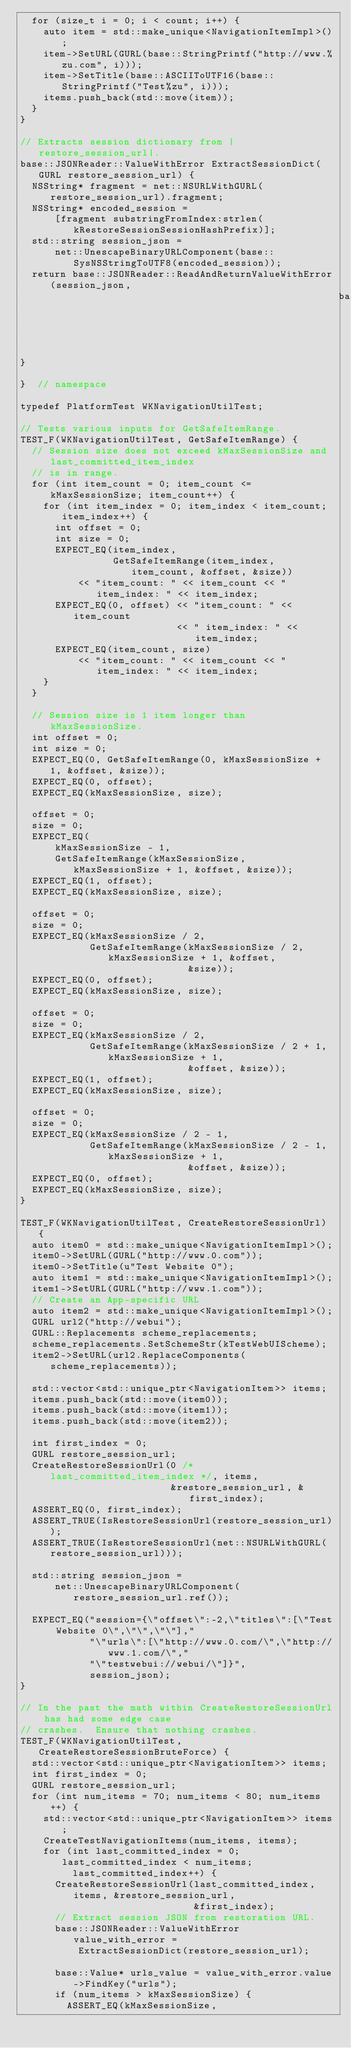<code> <loc_0><loc_0><loc_500><loc_500><_ObjectiveC_>  for (size_t i = 0; i < count; i++) {
    auto item = std::make_unique<NavigationItemImpl>();
    item->SetURL(GURL(base::StringPrintf("http://www.%zu.com", i)));
    item->SetTitle(base::ASCIIToUTF16(base::StringPrintf("Test%zu", i)));
    items.push_back(std::move(item));
  }
}

// Extracts session dictionary from |restore_session_url|.
base::JSONReader::ValueWithError ExtractSessionDict(GURL restore_session_url) {
  NSString* fragment = net::NSURLWithGURL(restore_session_url).fragment;
  NSString* encoded_session =
      [fragment substringFromIndex:strlen(kRestoreSessionSessionHashPrefix)];
  std::string session_json =
      net::UnescapeBinaryURLComponent(base::SysNSStringToUTF8(encoded_session));
  return base::JSONReader::ReadAndReturnValueWithError(session_json,
                                                       base::JSON_PARSE_RFC);
}

}  // namespace

typedef PlatformTest WKNavigationUtilTest;

// Tests various inputs for GetSafeItemRange.
TEST_F(WKNavigationUtilTest, GetSafeItemRange) {
  // Session size does not exceed kMaxSessionSize and last_committed_item_index
  // is in range.
  for (int item_count = 0; item_count <= kMaxSessionSize; item_count++) {
    for (int item_index = 0; item_index < item_count; item_index++) {
      int offset = 0;
      int size = 0;
      EXPECT_EQ(item_index,
                GetSafeItemRange(item_index, item_count, &offset, &size))
          << "item_count: " << item_count << " item_index: " << item_index;
      EXPECT_EQ(0, offset) << "item_count: " << item_count
                           << " item_index: " << item_index;
      EXPECT_EQ(item_count, size)
          << "item_count: " << item_count << " item_index: " << item_index;
    }
  }

  // Session size is 1 item longer than kMaxSessionSize.
  int offset = 0;
  int size = 0;
  EXPECT_EQ(0, GetSafeItemRange(0, kMaxSessionSize + 1, &offset, &size));
  EXPECT_EQ(0, offset);
  EXPECT_EQ(kMaxSessionSize, size);

  offset = 0;
  size = 0;
  EXPECT_EQ(
      kMaxSessionSize - 1,
      GetSafeItemRange(kMaxSessionSize, kMaxSessionSize + 1, &offset, &size));
  EXPECT_EQ(1, offset);
  EXPECT_EQ(kMaxSessionSize, size);

  offset = 0;
  size = 0;
  EXPECT_EQ(kMaxSessionSize / 2,
            GetSafeItemRange(kMaxSessionSize / 2, kMaxSessionSize + 1, &offset,
                             &size));
  EXPECT_EQ(0, offset);
  EXPECT_EQ(kMaxSessionSize, size);

  offset = 0;
  size = 0;
  EXPECT_EQ(kMaxSessionSize / 2,
            GetSafeItemRange(kMaxSessionSize / 2 + 1, kMaxSessionSize + 1,
                             &offset, &size));
  EXPECT_EQ(1, offset);
  EXPECT_EQ(kMaxSessionSize, size);

  offset = 0;
  size = 0;
  EXPECT_EQ(kMaxSessionSize / 2 - 1,
            GetSafeItemRange(kMaxSessionSize / 2 - 1, kMaxSessionSize + 1,
                             &offset, &size));
  EXPECT_EQ(0, offset);
  EXPECT_EQ(kMaxSessionSize, size);
}

TEST_F(WKNavigationUtilTest, CreateRestoreSessionUrl) {
  auto item0 = std::make_unique<NavigationItemImpl>();
  item0->SetURL(GURL("http://www.0.com"));
  item0->SetTitle(u"Test Website 0");
  auto item1 = std::make_unique<NavigationItemImpl>();
  item1->SetURL(GURL("http://www.1.com"));
  // Create an App-specific URL
  auto item2 = std::make_unique<NavigationItemImpl>();
  GURL url2("http://webui");
  GURL::Replacements scheme_replacements;
  scheme_replacements.SetSchemeStr(kTestWebUIScheme);
  item2->SetURL(url2.ReplaceComponents(scheme_replacements));

  std::vector<std::unique_ptr<NavigationItem>> items;
  items.push_back(std::move(item0));
  items.push_back(std::move(item1));
  items.push_back(std::move(item2));

  int first_index = 0;
  GURL restore_session_url;
  CreateRestoreSessionUrl(0 /* last_committed_item_index */, items,
                          &restore_session_url, &first_index);
  ASSERT_EQ(0, first_index);
  ASSERT_TRUE(IsRestoreSessionUrl(restore_session_url));
  ASSERT_TRUE(IsRestoreSessionUrl(net::NSURLWithGURL(restore_session_url)));

  std::string session_json =
      net::UnescapeBinaryURLComponent(restore_session_url.ref());

  EXPECT_EQ("session={\"offset\":-2,\"titles\":[\"Test Website 0\",\"\",\"\"],"
            "\"urls\":[\"http://www.0.com/\",\"http://www.1.com/\","
            "\"testwebui://webui/\"]}",
            session_json);
}

// In the past the math within CreateRestoreSessionUrl has had some edge case
// crashes.  Ensure that nothing crashes.
TEST_F(WKNavigationUtilTest, CreateRestoreSessionBruteForce) {
  std::vector<std::unique_ptr<NavigationItem>> items;
  int first_index = 0;
  GURL restore_session_url;
  for (int num_items = 70; num_items < 80; num_items++) {
    std::vector<std::unique_ptr<NavigationItem>> items;
    CreateTestNavigationItems(num_items, items);
    for (int last_committed_index = 0; last_committed_index < num_items;
         last_committed_index++) {
      CreateRestoreSessionUrl(last_committed_index, items, &restore_session_url,
                              &first_index);
      // Extract session JSON from restoration URL.
      base::JSONReader::ValueWithError value_with_error =
          ExtractSessionDict(restore_session_url);

      base::Value* urls_value = value_with_error.value->FindKey("urls");
      if (num_items > kMaxSessionSize) {
        ASSERT_EQ(kMaxSessionSize,</code> 